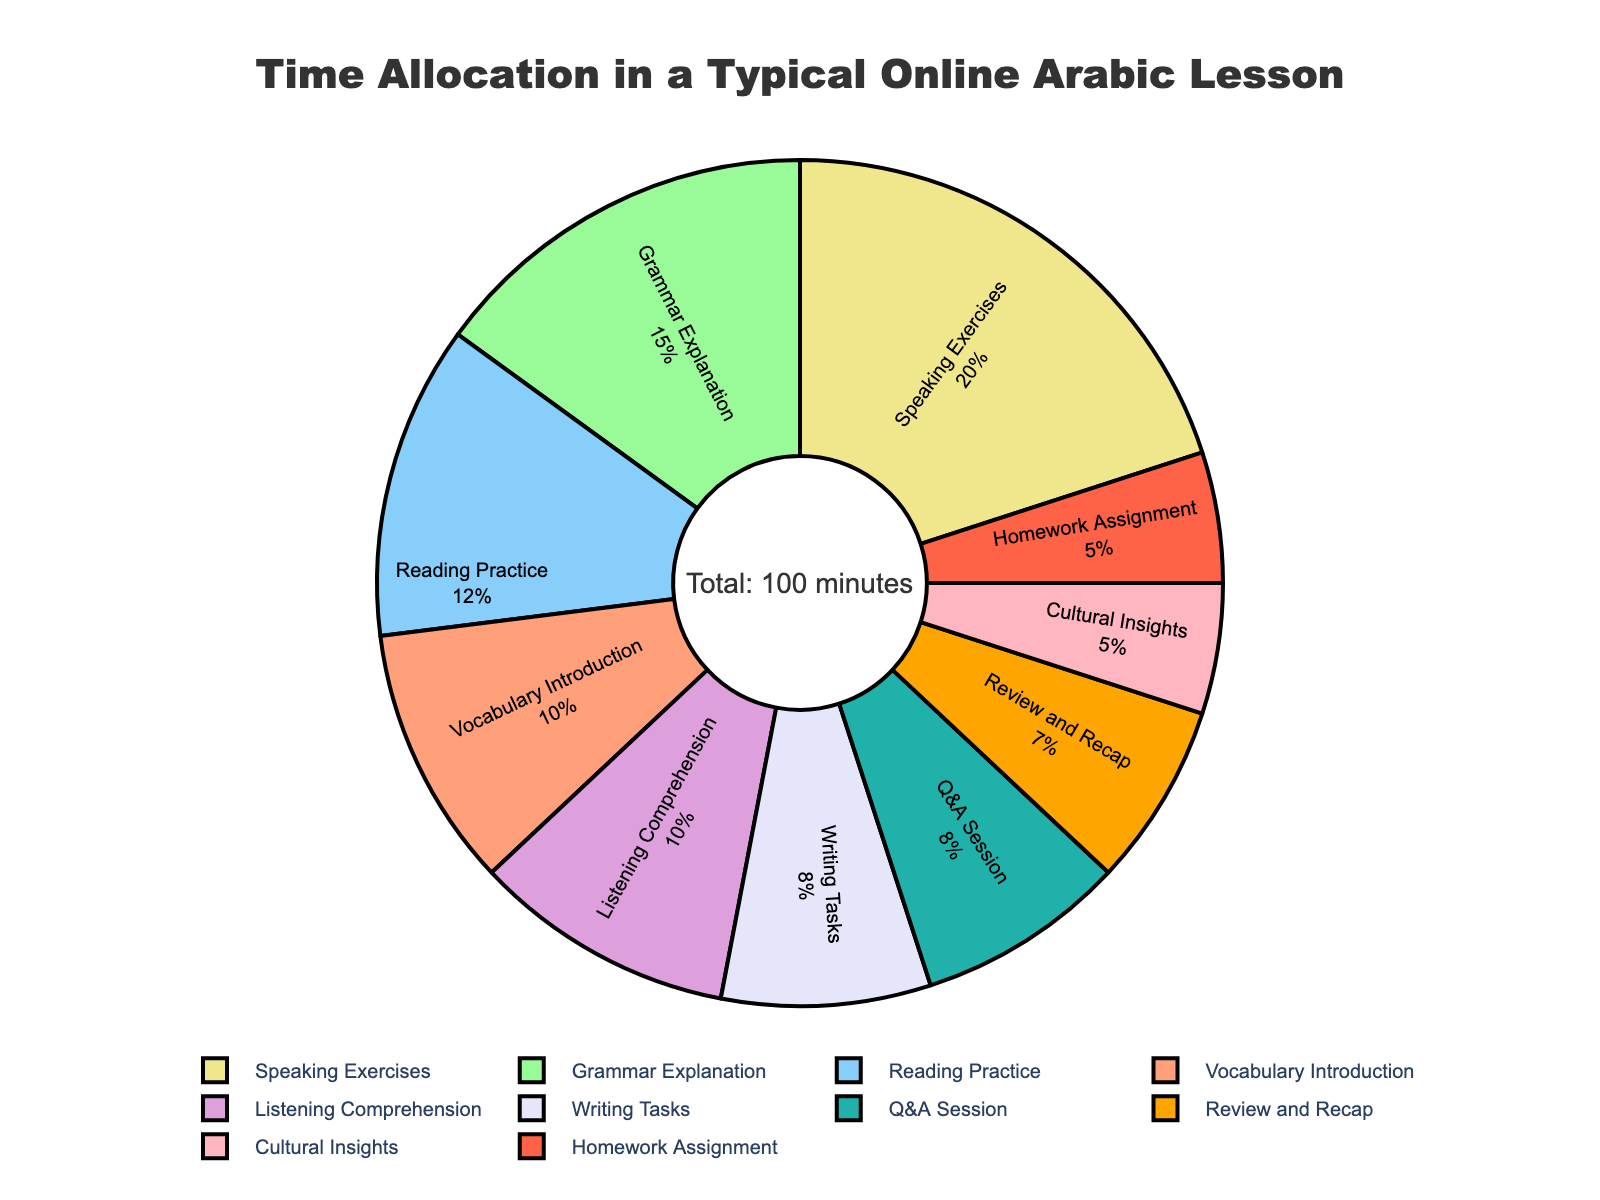What is the most time-consuming activity in the online Arabic lesson? The largest segment of the pie chart, which represents the activity taking the most minutes, is Speaking Exercises. By inspecting the chart, we can see that Speaking Exercises has the largest share.
Answer: Speaking Exercises Which activities have equal time allocations? By looking at the pie chart, we can see two segments that are the same size. The activities that both take 8 minutes are Writing Tasks and Q&A Session.
Answer: Writing Tasks and Q&A Session How much time is spent on Grammar Explanation compared to Reading Practice? Grammar Explanation is allocated 15 minutes, and Reading Practice is allocated 12 minutes. The difference in time is calculated as 15 - 12 = 3 minutes more for Grammar Explanation.
Answer: 3 minutes What percentage of the lesson is allocated to Cultural Insights? The segment for Cultural Insights represents 5 minutes out of the total 100 minutes. The percentage is calculated as (5 / 100) * 100 = 5%.
Answer: 5% How much time is spent on activities related to language production (Speaking Exercises and Writing Tasks)? Speaking Exercises take 20 minutes and Writing Tasks take 8 minutes. The total time is calculated by adding these two values: 20 + 8 = 28 minutes.
Answer: 28 minutes Is more time spent on Vocabulary Introduction or Review and Recap? The pie chart shows that Vocabulary Introduction is allocated 10 minutes, while Review and Recap is allocated 7 minutes. Comparing these values, we see that 10 minutes is more than 7 minutes.
Answer: Vocabulary Introduction What is the combined time allocation for Vocabulary Introduction, Listening Comprehension, and Homework Assignment? Vocabulary Introduction takes 10 minutes, Listening Comprehension takes 10 minutes, and Homework Assignment takes 5 minutes. Adding these times together: 10 + 10 + 5 = 25 minutes.
Answer: 25 minutes By how many minutes does Speaking Exercises exceed Listening Comprehension? Speaking Exercises is allocated 20 minutes, while Listening Comprehension is allocated 10 minutes. The difference is calculated as 20 - 10 = 10 minutes.
Answer: 10 minutes What fraction of the time is allocated to Q&A Session out of the total lesson time? The time for Q&A Session is 8 minutes, out of a total of 100 minutes. The fraction is calculated as 8 / 100 = 2/25.
Answer: 2/25 If 15 minutes are added equally to Reading Practice and Writing Tasks, what percentage of the total lesson would each be then? Initially, Reading Practice is 12 minutes and Writing Tasks is 8 minutes. Adding 15 minutes to each: Reading Practice: 12 + 15 = 27 minutes, Writing Tasks: 8 + 15 = 23 minutes. New total time: 100 + 15 + 15 = 130 minutes.
Percentage for Reading Practice: (27 / 130) * 100 ≈ 20.77%. 
Percentage for Writing Tasks: (23 / 130) * 100 ≈ 17.69%.
Answer: ≈ 20.77%, ≈ 17.69% 